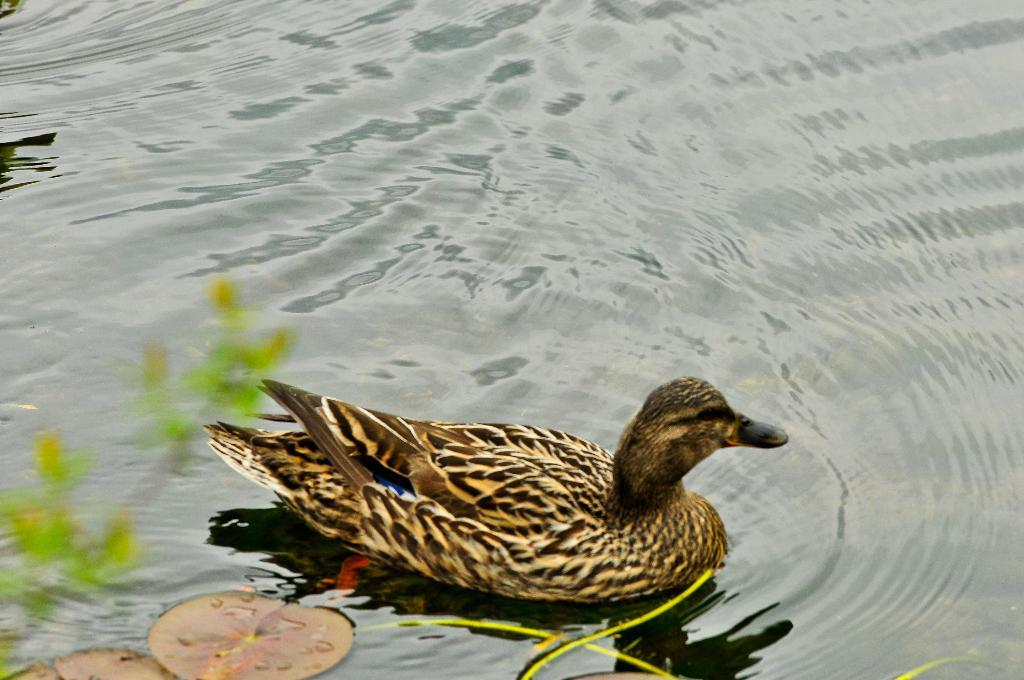What animal is present in the image? There is a duck in the image. Where is the duck located? The duck is on the water. What type of vegetation can be seen in the image? There are leaves in the image. Can you describe any other objects in the image? There are unspecified objects in the image. Is the duck's manager present in the image? There is no mention of a manager or any human presence in the image, so it cannot be determined if the duck's manager is present. 